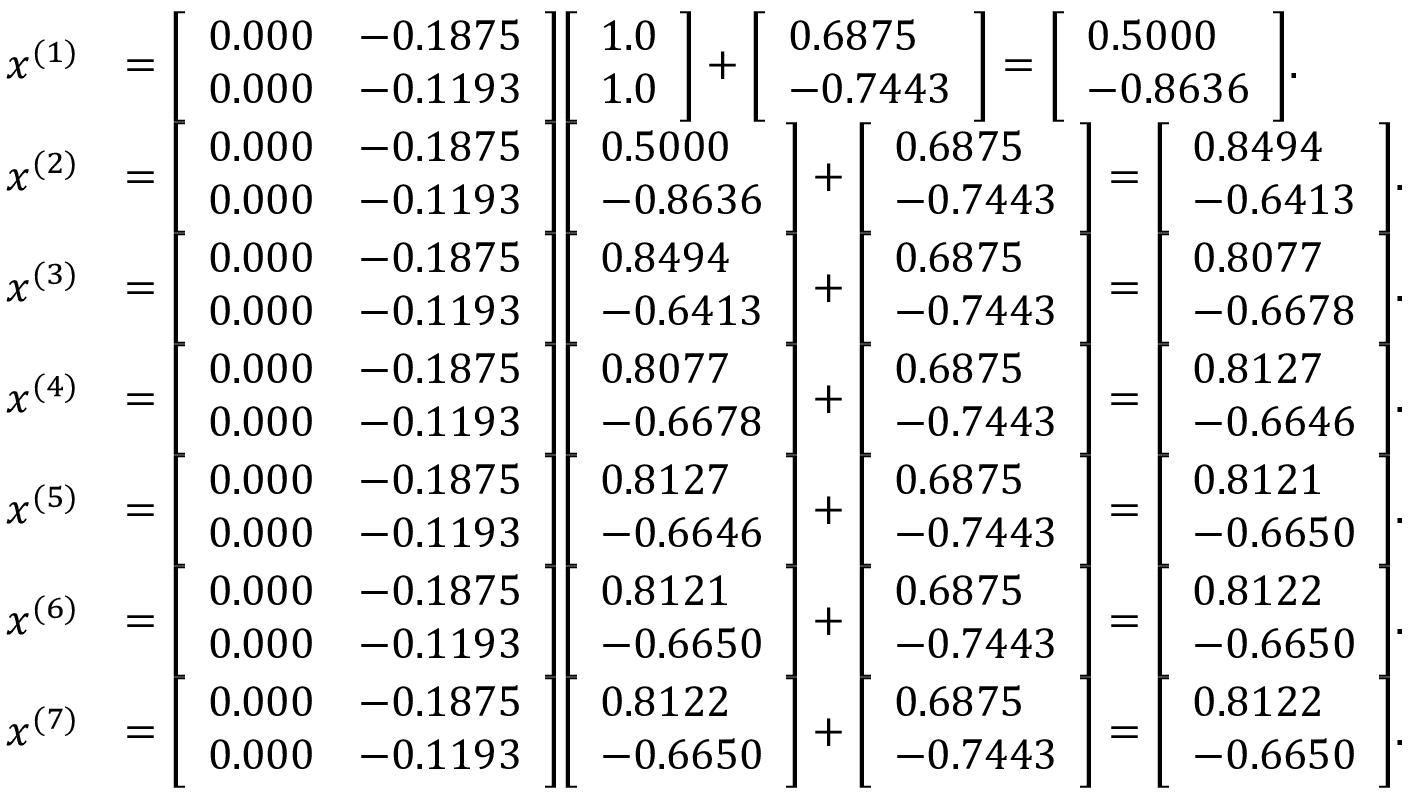Convert formula to latex. <formula><loc_0><loc_0><loc_500><loc_500>{ \begin{array} { r l } { x ^ { ( 1 ) } } & { = { \left [ \begin{array} { l l } { 0 . 0 0 0 } & { - 0 . 1 8 7 5 } \\ { 0 . 0 0 0 } & { - 0 . 1 1 9 3 } \end{array} \right ] } { \left [ \begin{array} { l } { 1 . 0 } \\ { 1 . 0 } \end{array} \right ] } + { \left [ \begin{array} { l } { 0 . 6 8 7 5 } \\ { - 0 . 7 4 4 3 } \end{array} \right ] } = { \left [ \begin{array} { l } { 0 . 5 0 0 0 } \\ { - 0 . 8 6 3 6 } \end{array} \right ] } . } \\ { x ^ { ( 2 ) } } & { = { \left [ \begin{array} { l l } { 0 . 0 0 0 } & { - 0 . 1 8 7 5 } \\ { 0 . 0 0 0 } & { - 0 . 1 1 9 3 } \end{array} \right ] } { \left [ \begin{array} { l } { 0 . 5 0 0 0 } \\ { - 0 . 8 6 3 6 } \end{array} \right ] } + { \left [ \begin{array} { l } { 0 . 6 8 7 5 } \\ { - 0 . 7 4 4 3 } \end{array} \right ] } = { \left [ \begin{array} { l } { 0 . 8 4 9 4 } \\ { - 0 . 6 4 1 3 } \end{array} \right ] } . } \\ { x ^ { ( 3 ) } } & { = { \left [ \begin{array} { l l } { 0 . 0 0 0 } & { - 0 . 1 8 7 5 } \\ { 0 . 0 0 0 } & { - 0 . 1 1 9 3 } \end{array} \right ] } { \left [ \begin{array} { l } { 0 . 8 4 9 4 } \\ { - 0 . 6 4 1 3 } \end{array} \right ] } + { \left [ \begin{array} { l } { 0 . 6 8 7 5 } \\ { - 0 . 7 4 4 3 } \end{array} \right ] } = { \left [ \begin{array} { l } { 0 . 8 0 7 7 } \\ { - 0 . 6 6 7 8 } \end{array} \right ] } . } \\ { x ^ { ( 4 ) } } & { = { \left [ \begin{array} { l l } { 0 . 0 0 0 } & { - 0 . 1 8 7 5 } \\ { 0 . 0 0 0 } & { - 0 . 1 1 9 3 } \end{array} \right ] } { \left [ \begin{array} { l } { 0 . 8 0 7 7 } \\ { - 0 . 6 6 7 8 } \end{array} \right ] } + { \left [ \begin{array} { l } { 0 . 6 8 7 5 } \\ { - 0 . 7 4 4 3 } \end{array} \right ] } = { \left [ \begin{array} { l } { 0 . 8 1 2 7 } \\ { - 0 . 6 6 4 6 } \end{array} \right ] } . } \\ { x ^ { ( 5 ) } } & { = { \left [ \begin{array} { l l } { 0 . 0 0 0 } & { - 0 . 1 8 7 5 } \\ { 0 . 0 0 0 } & { - 0 . 1 1 9 3 } \end{array} \right ] } { \left [ \begin{array} { l } { 0 . 8 1 2 7 } \\ { - 0 . 6 6 4 6 } \end{array} \right ] } + { \left [ \begin{array} { l } { 0 . 6 8 7 5 } \\ { - 0 . 7 4 4 3 } \end{array} \right ] } = { \left [ \begin{array} { l } { 0 . 8 1 2 1 } \\ { - 0 . 6 6 5 0 } \end{array} \right ] } . } \\ { x ^ { ( 6 ) } } & { = { \left [ \begin{array} { l l } { 0 . 0 0 0 } & { - 0 . 1 8 7 5 } \\ { 0 . 0 0 0 } & { - 0 . 1 1 9 3 } \end{array} \right ] } { \left [ \begin{array} { l } { 0 . 8 1 2 1 } \\ { - 0 . 6 6 5 0 } \end{array} \right ] } + { \left [ \begin{array} { l } { 0 . 6 8 7 5 } \\ { - 0 . 7 4 4 3 } \end{array} \right ] } = { \left [ \begin{array} { l } { 0 . 8 1 2 2 } \\ { - 0 . 6 6 5 0 } \end{array} \right ] } . } \\ { x ^ { ( 7 ) } } & { = { \left [ \begin{array} { l l } { 0 . 0 0 0 } & { - 0 . 1 8 7 5 } \\ { 0 . 0 0 0 } & { - 0 . 1 1 9 3 } \end{array} \right ] } { \left [ \begin{array} { l } { 0 . 8 1 2 2 } \\ { - 0 . 6 6 5 0 } \end{array} \right ] } + { \left [ \begin{array} { l } { 0 . 6 8 7 5 } \\ { - 0 . 7 4 4 3 } \end{array} \right ] } = { \left [ \begin{array} { l } { 0 . 8 1 2 2 } \\ { - 0 . 6 6 5 0 } \end{array} \right ] } . } \end{array} }</formula> 